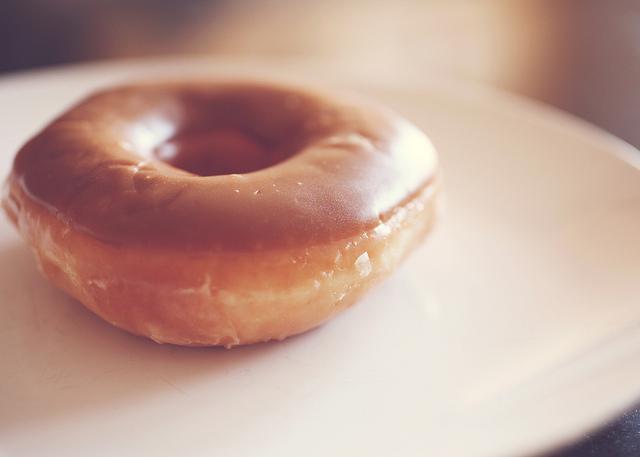How many doughnuts are there?
Give a very brief answer. 1. How many donuts are on the plate?
Give a very brief answer. 1. 